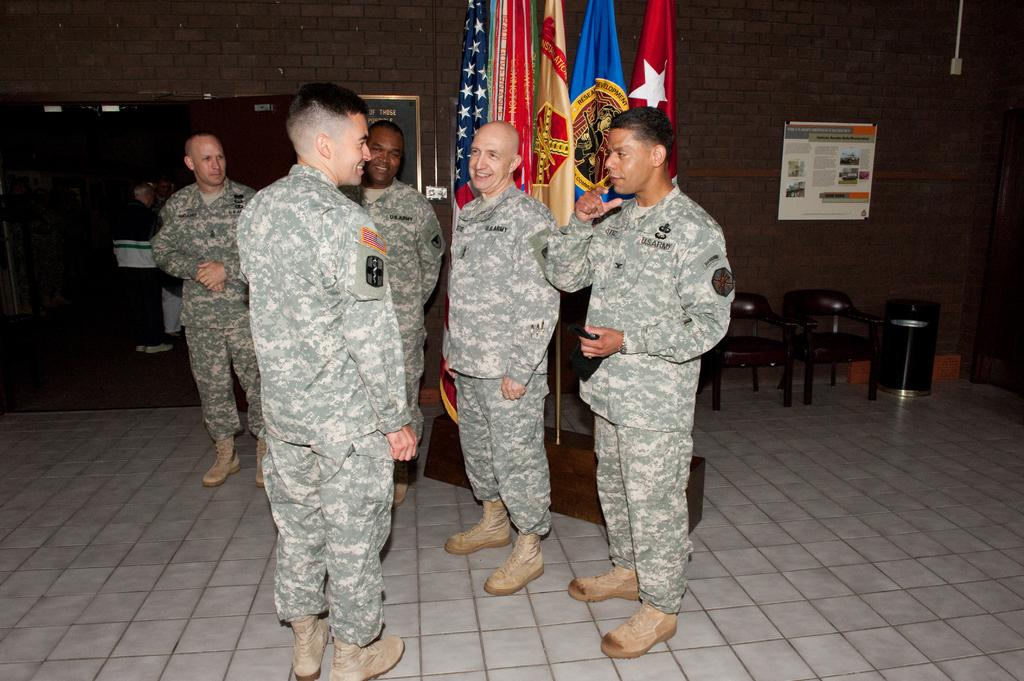Where was the image taken? The image was taken in a room. What are the five men in the center of the image doing? The five men are standing and talking in the center of the image. What can be seen in the background of the image? In the background of the image, there are chairs, flags, boards, a wall, and a door. What type of stone is being used to decorate the cakes in the image? There are no cakes or stone present in the image; it features five men standing and talking in a room with various background elements. 